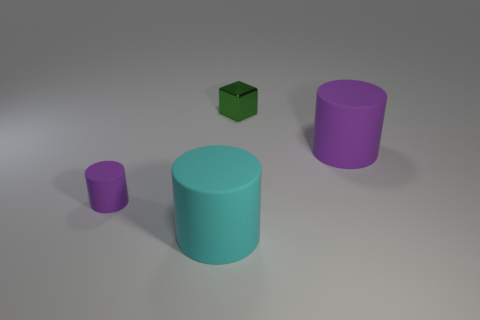Add 2 small cyan rubber blocks. How many objects exist? 6 Subtract all blocks. How many objects are left? 3 Subtract 0 gray cylinders. How many objects are left? 4 Subtract all big cyan cylinders. Subtract all small cylinders. How many objects are left? 2 Add 2 tiny purple rubber things. How many tiny purple rubber things are left? 3 Add 3 tiny purple spheres. How many tiny purple spheres exist? 3 